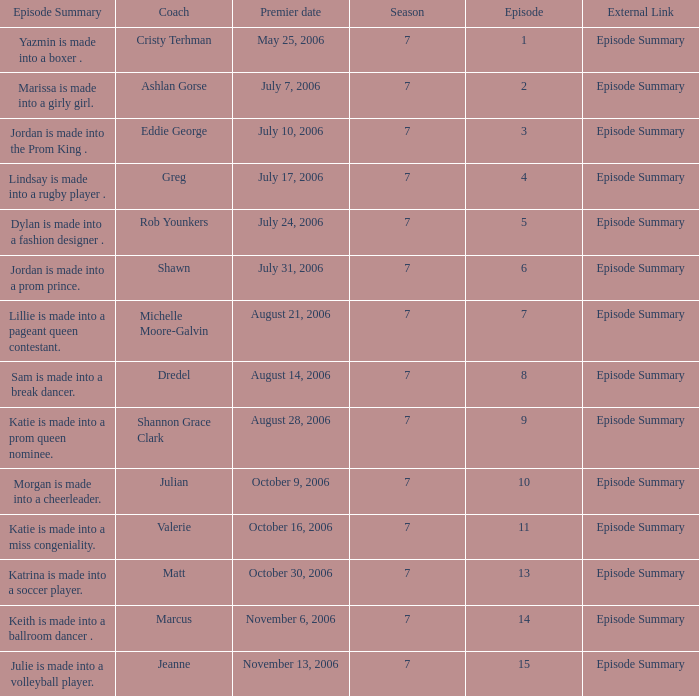Can you parse all the data within this table? {'header': ['Episode Summary', 'Coach', 'Premier date', 'Season', 'Episode', 'External Link'], 'rows': [['Yazmin is made into a boxer .', 'Cristy Terhman', 'May 25, 2006', '7', '1', 'Episode Summary'], ['Marissa is made into a girly girl.', 'Ashlan Gorse', 'July 7, 2006', '7', '2', 'Episode Summary'], ['Jordan is made into the Prom King .', 'Eddie George', 'July 10, 2006', '7', '3', 'Episode Summary'], ['Lindsay is made into a rugby player .', 'Greg', 'July 17, 2006', '7', '4', 'Episode Summary'], ['Dylan is made into a fashion designer .', 'Rob Younkers', 'July 24, 2006', '7', '5', 'Episode Summary'], ['Jordan is made into a prom prince.', 'Shawn', 'July 31, 2006', '7', '6', 'Episode Summary'], ['Lillie is made into a pageant queen contestant.', 'Michelle Moore-Galvin', 'August 21, 2006', '7', '7', 'Episode Summary'], ['Sam is made into a break dancer.', 'Dredel', 'August 14, 2006', '7', '8', 'Episode Summary'], ['Katie is made into a prom queen nominee.', 'Shannon Grace Clark', 'August 28, 2006', '7', '9', 'Episode Summary'], ['Morgan is made into a cheerleader.', 'Julian', 'October 9, 2006', '7', '10', 'Episode Summary'], ['Katie is made into a miss congeniality.', 'Valerie', 'October 16, 2006', '7', '11', 'Episode Summary'], ['Katrina is made into a soccer player.', 'Matt', 'October 30, 2006', '7', '13', 'Episode Summary'], ['Keith is made into a ballroom dancer .', 'Marcus', 'November 6, 2006', '7', '14', 'Episode Summary'], ['Julie is made into a volleyball player.', 'Jeanne', 'November 13, 2006', '7', '15', 'Episode Summary']]} What the summary of episode 15? Julie is made into a volleyball player. 